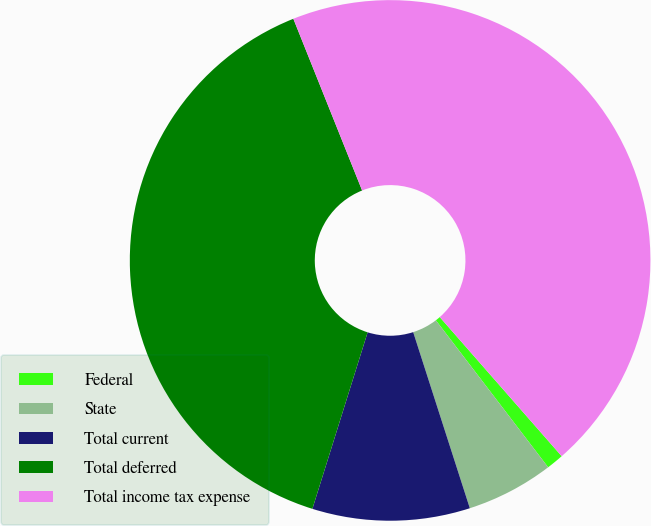Convert chart to OTSL. <chart><loc_0><loc_0><loc_500><loc_500><pie_chart><fcel>Federal<fcel>State<fcel>Total current<fcel>Total deferred<fcel>Total income tax expense<nl><fcel>1.07%<fcel>5.43%<fcel>9.78%<fcel>39.11%<fcel>44.61%<nl></chart> 